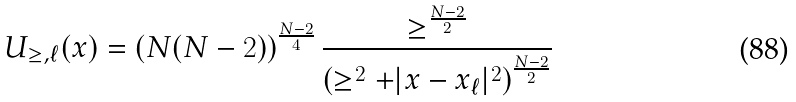Convert formula to latex. <formula><loc_0><loc_0><loc_500><loc_500>U _ { \geq , \ell } ( x ) = \left ( N ( N - 2 ) \right ) ^ { \frac { N - 2 } { 4 } } \frac { \geq ^ { \frac { N - 2 } { 2 } } } { \left ( \geq ^ { 2 } + | x - x _ { \ell } | ^ { 2 } \right ) ^ { \frac { N - 2 } { 2 } } }</formula> 